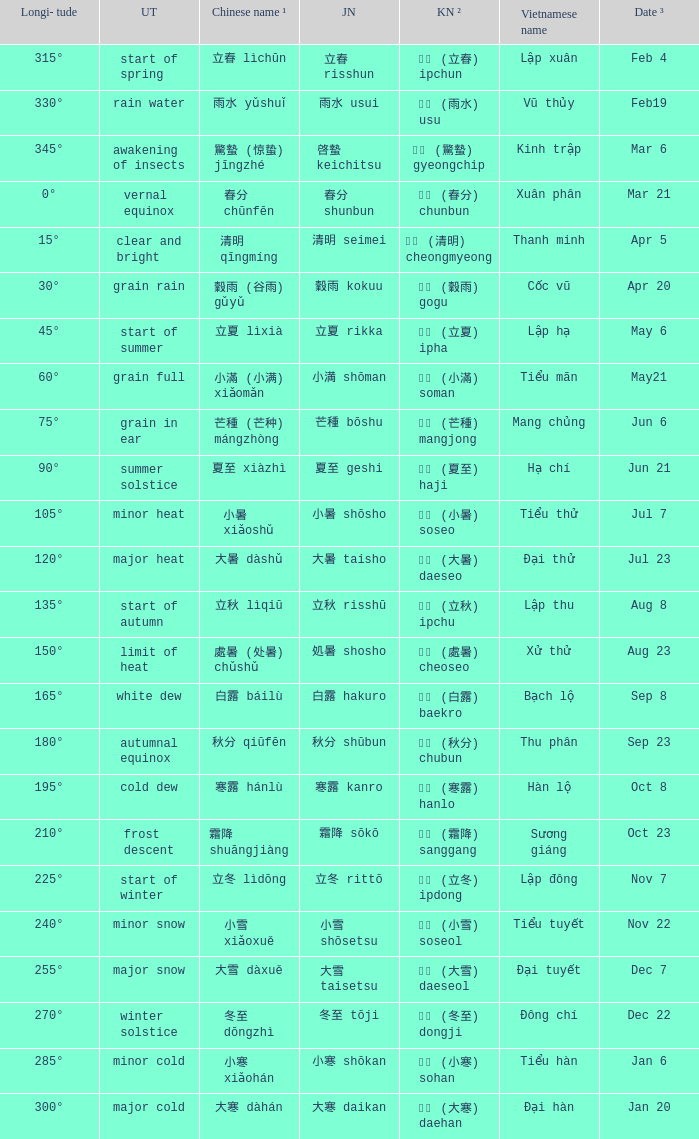WHICH Usual translation is on jun 21? Summer solstice. 